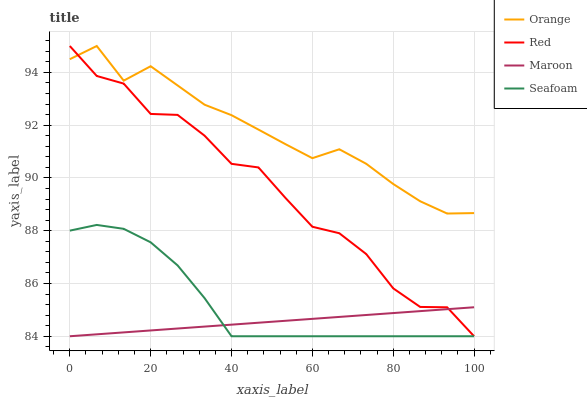Does Maroon have the minimum area under the curve?
Answer yes or no. Yes. Does Orange have the maximum area under the curve?
Answer yes or no. Yes. Does Red have the minimum area under the curve?
Answer yes or no. No. Does Red have the maximum area under the curve?
Answer yes or no. No. Is Maroon the smoothest?
Answer yes or no. Yes. Is Red the roughest?
Answer yes or no. Yes. Is Red the smoothest?
Answer yes or no. No. Is Maroon the roughest?
Answer yes or no. No. Does Maroon have the lowest value?
Answer yes or no. Yes. Does Red have the highest value?
Answer yes or no. Yes. Does Maroon have the highest value?
Answer yes or no. No. Is Maroon less than Orange?
Answer yes or no. Yes. Is Orange greater than Maroon?
Answer yes or no. Yes. Does Maroon intersect Red?
Answer yes or no. Yes. Is Maroon less than Red?
Answer yes or no. No. Is Maroon greater than Red?
Answer yes or no. No. Does Maroon intersect Orange?
Answer yes or no. No. 